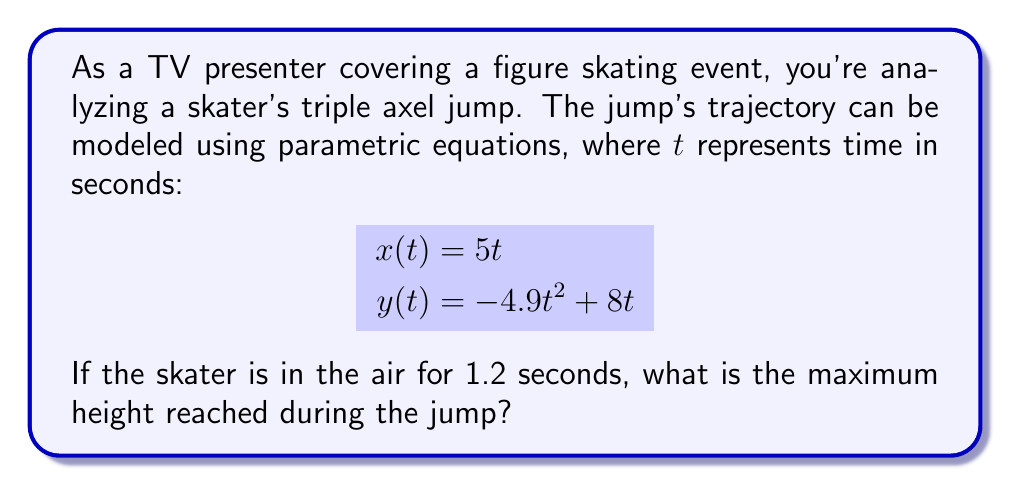What is the answer to this math problem? To find the maximum height of the jump, we need to follow these steps:

1) The vertical component of the jump is represented by $y(t) = -4.9t^2 + 8t$.

2) To find the maximum height, we need to find the vertex of this parabola. The vertex occurs at the time when the vertical velocity is zero.

3) The vertical velocity is the derivative of $y(t)$:
   $$y'(t) = -9.8t + 8$$

4) Set $y'(t) = 0$ and solve for $t$:
   $$-9.8t + 8 = 0$$
   $$-9.8t = -8$$
   $$t = \frac{8}{9.8} \approx 0.816 \text{ seconds}$$

5) This is the time when the skater reaches maximum height. Plug this value of $t$ back into the original equation for $y(t)$:

   $$y(0.816) = -4.9(0.816)^2 + 8(0.816)$$
   $$\approx -3.262 + 6.528$$
   $$\approx 3.266 \text{ meters}$$

Therefore, the maximum height reached during the jump is approximately 3.266 meters.
Answer: $3.266$ meters 